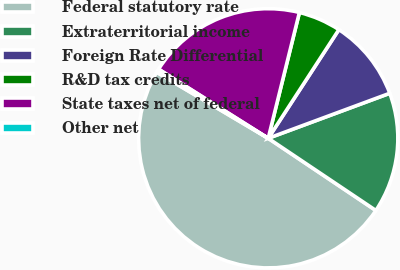Convert chart. <chart><loc_0><loc_0><loc_500><loc_500><pie_chart><fcel>Federal statutory rate<fcel>Extraterritorial income<fcel>Foreign Rate Differential<fcel>R&D tax credits<fcel>State taxes net of federal<fcel>Other net<nl><fcel>49.12%<fcel>15.05%<fcel>10.18%<fcel>5.31%<fcel>19.92%<fcel>0.44%<nl></chart> 